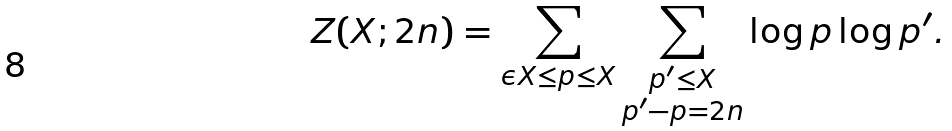Convert formula to latex. <formula><loc_0><loc_0><loc_500><loc_500>Z ( X ; 2 n ) = \sum _ { \epsilon X \leq p \leq X } \sum _ { \substack { p ^ { \prime } \leq X \\ p ^ { \prime } - p = 2 n } } \log p \log p ^ { \prime } .</formula> 